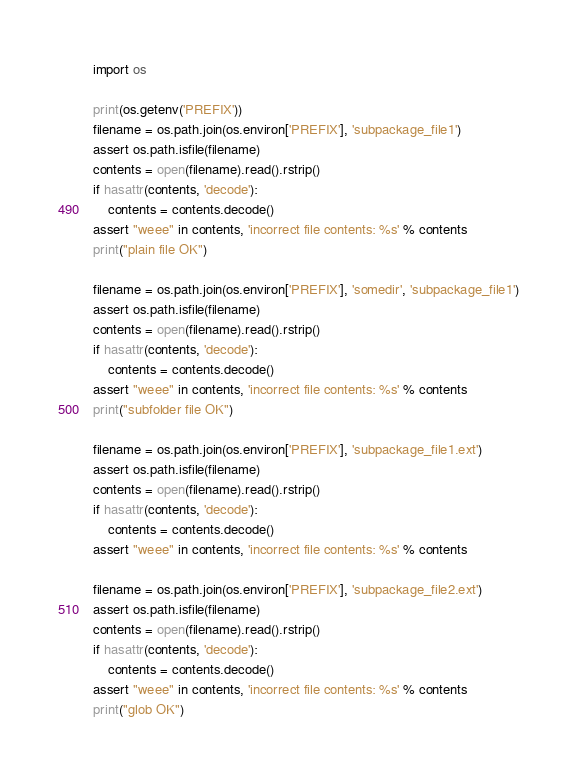Convert code to text. <code><loc_0><loc_0><loc_500><loc_500><_Python_>import os

print(os.getenv('PREFIX'))
filename = os.path.join(os.environ['PREFIX'], 'subpackage_file1')
assert os.path.isfile(filename)
contents = open(filename).read().rstrip()
if hasattr(contents, 'decode'):
    contents = contents.decode()
assert "weee" in contents, 'incorrect file contents: %s' % contents
print("plain file OK")

filename = os.path.join(os.environ['PREFIX'], 'somedir', 'subpackage_file1')
assert os.path.isfile(filename)
contents = open(filename).read().rstrip()
if hasattr(contents, 'decode'):
    contents = contents.decode()
assert "weee" in contents, 'incorrect file contents: %s' % contents
print("subfolder file OK")

filename = os.path.join(os.environ['PREFIX'], 'subpackage_file1.ext')
assert os.path.isfile(filename)
contents = open(filename).read().rstrip()
if hasattr(contents, 'decode'):
    contents = contents.decode()
assert "weee" in contents, 'incorrect file contents: %s' % contents

filename = os.path.join(os.environ['PREFIX'], 'subpackage_file2.ext')
assert os.path.isfile(filename)
contents = open(filename).read().rstrip()
if hasattr(contents, 'decode'):
    contents = contents.decode()
assert "weee" in contents, 'incorrect file contents: %s' % contents
print("glob OK")
</code> 